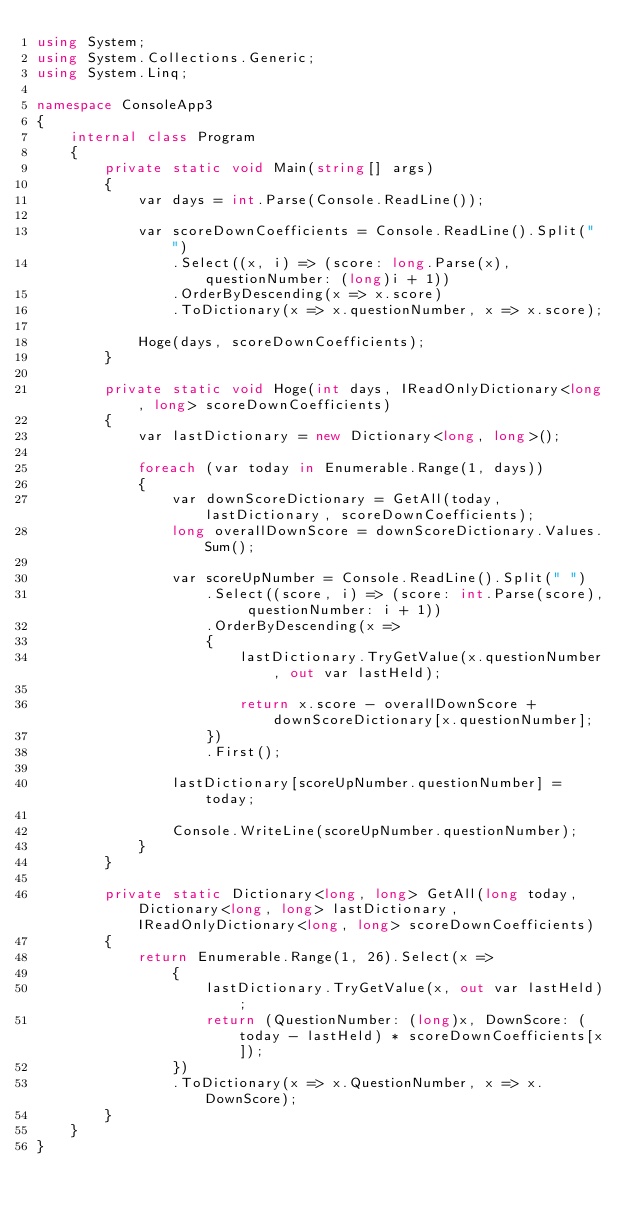<code> <loc_0><loc_0><loc_500><loc_500><_C#_>using System;
using System.Collections.Generic;
using System.Linq;

namespace ConsoleApp3
{
    internal class Program
    {
        private static void Main(string[] args)
        {
            var days = int.Parse(Console.ReadLine());

            var scoreDownCoefficients = Console.ReadLine().Split(" ")
                .Select((x, i) => (score: long.Parse(x), questionNumber: (long)i + 1))
                .OrderByDescending(x => x.score)
                .ToDictionary(x => x.questionNumber, x => x.score);

            Hoge(days, scoreDownCoefficients);
        }

        private static void Hoge(int days, IReadOnlyDictionary<long, long> scoreDownCoefficients)
        {
            var lastDictionary = new Dictionary<long, long>();

            foreach (var today in Enumerable.Range(1, days))
            {
                var downScoreDictionary = GetAll(today, lastDictionary, scoreDownCoefficients);
                long overallDownScore = downScoreDictionary.Values.Sum();

                var scoreUpNumber = Console.ReadLine().Split(" ")
                    .Select((score, i) => (score: int.Parse(score), questionNumber: i + 1))
                    .OrderByDescending(x =>
                    {
                        lastDictionary.TryGetValue(x.questionNumber, out var lastHeld);

                        return x.score - overallDownScore + downScoreDictionary[x.questionNumber];
                    })
                    .First();

                lastDictionary[scoreUpNumber.questionNumber] = today;

                Console.WriteLine(scoreUpNumber.questionNumber);
            }
        }

        private static Dictionary<long, long> GetAll(long today, Dictionary<long, long> lastDictionary, IReadOnlyDictionary<long, long> scoreDownCoefficients)
        {
            return Enumerable.Range(1, 26).Select(x =>
                {
                    lastDictionary.TryGetValue(x, out var lastHeld);
                    return (QuestionNumber: (long)x, DownScore: (today - lastHeld) * scoreDownCoefficients[x]);
                })
                .ToDictionary(x => x.QuestionNumber, x => x.DownScore);
        }
    }
}
</code> 